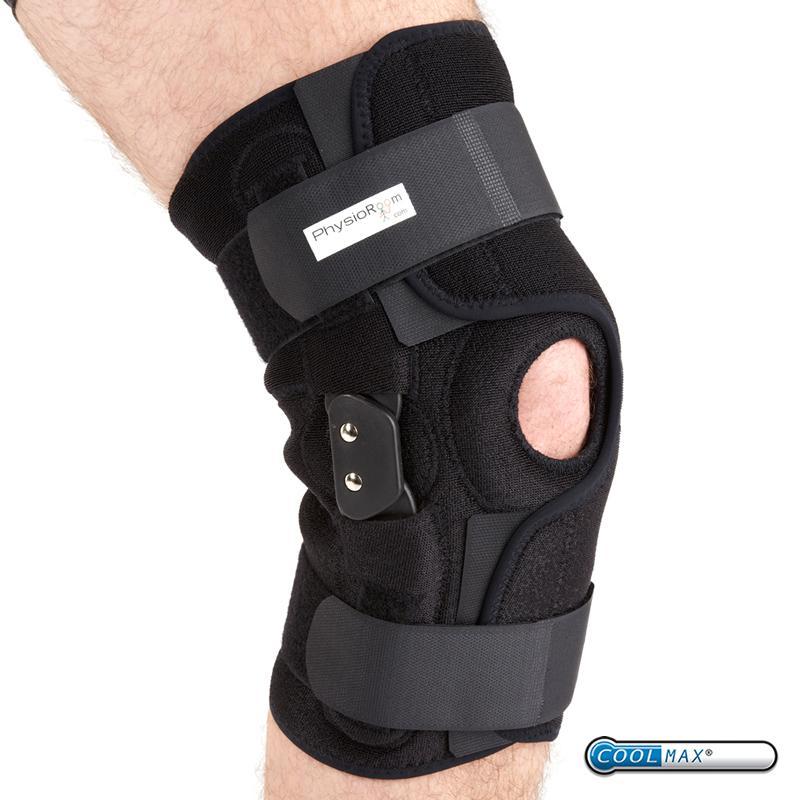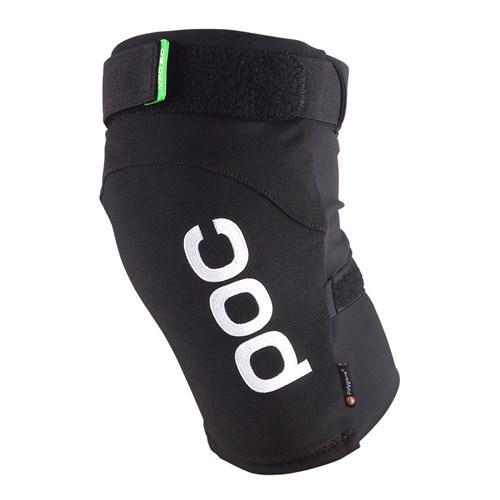The first image is the image on the left, the second image is the image on the right. For the images displayed, is the sentence "A total of two knee pads without a knee opening are shown." factually correct? Answer yes or no. No. 